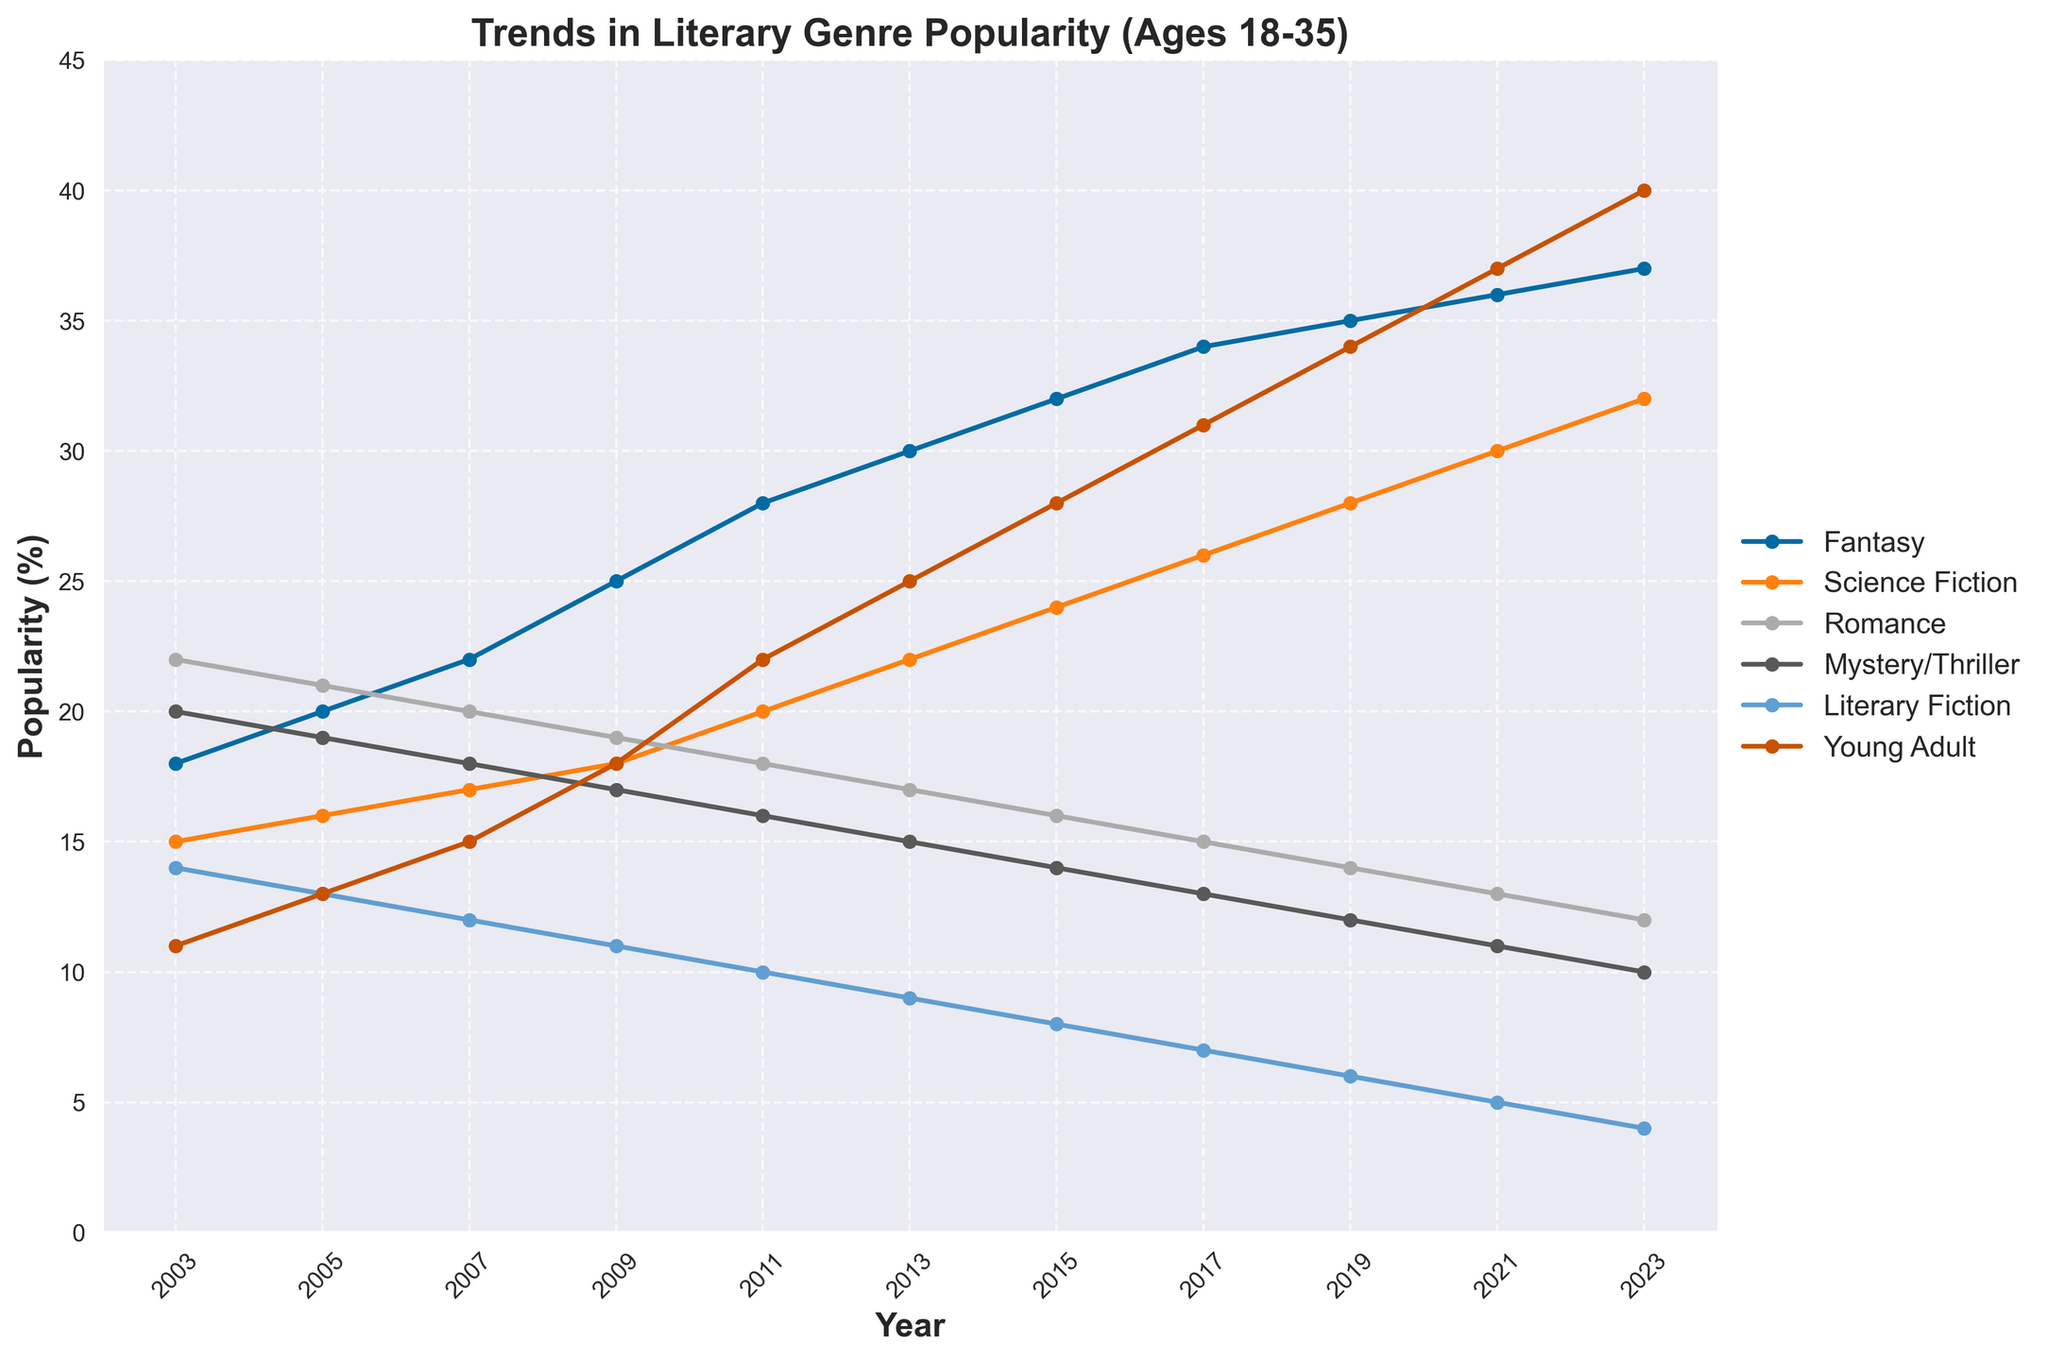What genre has shown the most consistent increase in popularity over the 20 years? By observing the trends, you can see which genre has steadily risen without many fluctuations. Fantasy shows a consistent upward trend from 18% to 37%.
Answer: Fantasy What's the difference in popularity between Science Fiction and Romance in 2023? In 2023, Science Fiction is at 32% and Romance at 12%. To find the difference, subtract 12 from 32.
Answer: 20% Which genre showed the most rapid increase between 2017 and 2021? From 2017 to 2021, Young Adult rises from 31% to 37%, while other genres show smaller increases or even decrease.
Answer: Young Adult How do the popularity trends of Fantasy and Literary Fiction compare over the period? Fantasy shows a continuous increase, starting at 18% in 2003 and reaching 37% in 2023, while Literary Fiction steadily declines from 14% to 4% over the same period.
Answer: Fantasy increases, Literary Fiction decreases What is the combined popularity of Mystery/Thriller and Literary Fiction in 2011? In 2011, Mystery/Thriller is 16% and Literary Fiction is 10%. Add these to find the combined popularity: 16 + 10.
Answer: 26% Which genre dominates popularity in 2023? By looking at the highest point in 2023, Young Adult reaches 40%, higher than all other genres.
Answer: Young Adult What is the average popularity of Romance over the 20 years? Sum the Romance values (22, 21, 20, 19, 18, 17, 16, 15, 14, 13, 12) which equals 187, then divide by the number of data points (11).
Answer: 17% Between 2003 and 2007, did any genre's popularity decrease? By observing each line, Romance goes from 22% to 20% and Literary Fiction from 14% to 12%. Both show a decrease.
Answer: Yes, both Romance and Literary Fiction What's the difference between the highest and lowest popularity points of Young Adult? The highest is 40% (2023) and the lowest is 11% (2003). Subtract 11 from 40 to find the difference.
Answer: 29% Which two genres are closest in popularity in 2005? By comparing values, Literary Fiction and Young Adult are both at 13% in 2005, showing they are closest in popularity.
Answer: Literary Fiction and Young Adult 